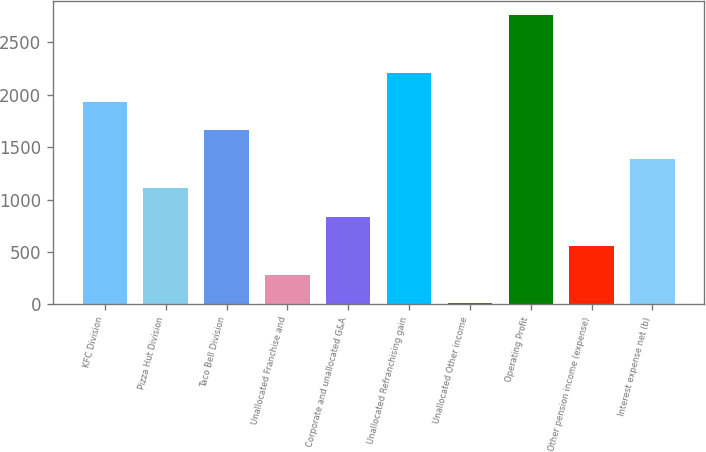Convert chart to OTSL. <chart><loc_0><loc_0><loc_500><loc_500><bar_chart><fcel>KFC Division<fcel>Pizza Hut Division<fcel>Taco Bell Division<fcel>Unallocated Franchise and<fcel>Corporate and unallocated G&A<fcel>Unallocated Refranchising gain<fcel>Unallocated Other income<fcel>Operating Profit<fcel>Other pension income (expense)<fcel>Interest expense net (b)<nl><fcel>1935.1<fcel>1109.2<fcel>1659.8<fcel>283.3<fcel>833.9<fcel>2210.4<fcel>8<fcel>2761<fcel>558.6<fcel>1384.5<nl></chart> 